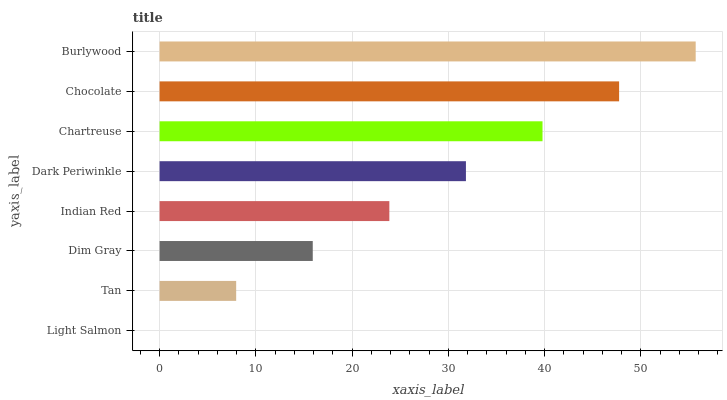Is Light Salmon the minimum?
Answer yes or no. Yes. Is Burlywood the maximum?
Answer yes or no. Yes. Is Tan the minimum?
Answer yes or no. No. Is Tan the maximum?
Answer yes or no. No. Is Tan greater than Light Salmon?
Answer yes or no. Yes. Is Light Salmon less than Tan?
Answer yes or no. Yes. Is Light Salmon greater than Tan?
Answer yes or no. No. Is Tan less than Light Salmon?
Answer yes or no. No. Is Dark Periwinkle the high median?
Answer yes or no. Yes. Is Indian Red the low median?
Answer yes or no. Yes. Is Chartreuse the high median?
Answer yes or no. No. Is Light Salmon the low median?
Answer yes or no. No. 